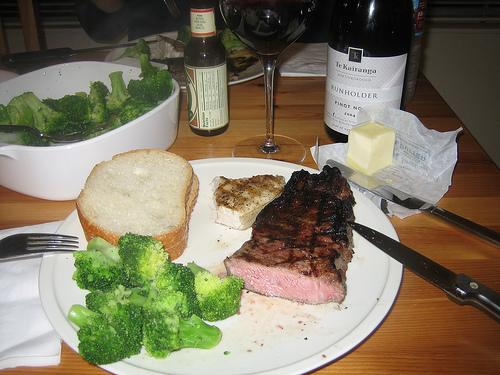Identify the key food components in the frame and mention the utensils visible. The key food components are steak, bread, and broccoli, with a fork, butter knife, and steak knife visible. List down the primary culinary components and their position on the table. Steak on a white plate, fork and napkin on the left, butter knife on butter wrapper, glass and bottle of wine, and a serving dish with broccoli. Briefly mention the main food items in the image and what color the plate is. There's a steak, broccoli, and white bread on a white plate. State the main components of the meal served and any beverages present in the image. The meal includes a steak, white bread, and broccoli, accompanied by a glass and bottle of wine. Describe the general presentation of the meal on the plate, paying attention to the colors. A visually appealing meal of steak, green broccoli, and white bread sits on a pristine white plate. Highlight the key components of the dining scene and the state of the wine glass. The scene includes a plate of steak, bread, and broccoli, with cutlery and a paper napkin, and a wine glass filled with wine. Write about the main food items on the plate and their overall appearance. The plate has a medium well steak, a small portion of green broccoli, and two slices of white bread, all looking fresh and delicious. What are the three main food items on the table and describe the cook of the steak in brief? The three main food items are steak, white bread, and broccoli, with the steak being cooked medium well. Mention the key components of this meal and the overall preparation quality of the steak. The meal consists of steak, broccoli, and bread, with the steak cooked medium-well and appearing quite appetizing. Enumerate the food items on the plate and indicate the wine and butter's presence on the table. The plate holds steak, broccoli, and bread, and there's also wine and a stick of butter on the table. 